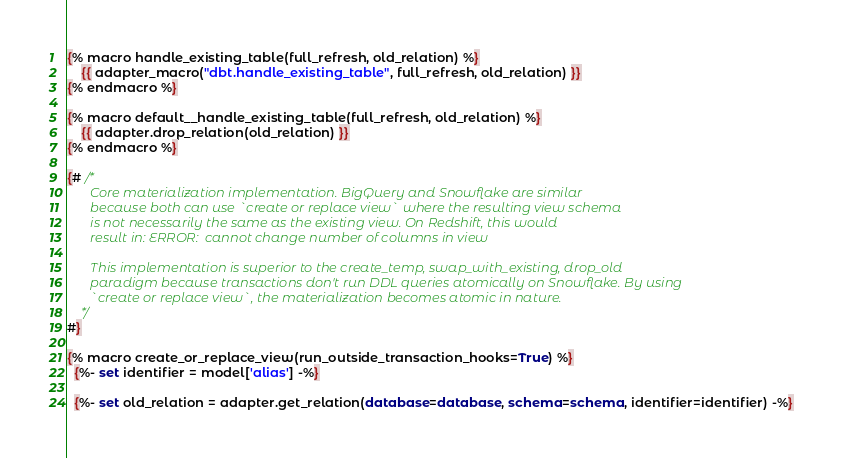<code> <loc_0><loc_0><loc_500><loc_500><_SQL_>
{% macro handle_existing_table(full_refresh, old_relation) %}
    {{ adapter_macro("dbt.handle_existing_table", full_refresh, old_relation) }}
{% endmacro %}

{% macro default__handle_existing_table(full_refresh, old_relation) %}
    {{ adapter.drop_relation(old_relation) }}
{% endmacro %}

{# /*
       Core materialization implementation. BigQuery and Snowflake are similar
       because both can use `create or replace view` where the resulting view schema
       is not necessarily the same as the existing view. On Redshift, this would
       result in: ERROR:  cannot change number of columns in view

       This implementation is superior to the create_temp, swap_with_existing, drop_old
       paradigm because transactions don't run DDL queries atomically on Snowflake. By using
       `create or replace view`, the materialization becomes atomic in nature.
    */
#}

{% macro create_or_replace_view(run_outside_transaction_hooks=True) %}
  {%- set identifier = model['alias'] -%}

  {%- set old_relation = adapter.get_relation(database=database, schema=schema, identifier=identifier) -%}
</code> 